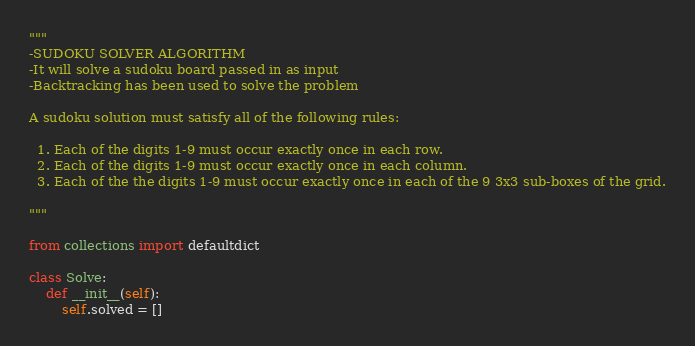Convert code to text. <code><loc_0><loc_0><loc_500><loc_500><_Python_>"""
-SUDOKU SOLVER ALGORITHM
-It will solve a sudoku board passed in as input
-Backtracking has been used to solve the problem

A sudoku solution must satisfy all of the following rules:

  1. Each of the digits 1-9 must occur exactly once in each row.
  2. Each of the digits 1-9 must occur exactly once in each column.
  3. Each of the the digits 1-9 must occur exactly once in each of the 9 3x3 sub-boxes of the grid.

"""

from collections import defaultdict

class Solve:
    def __init__(self):
        self.solved = []
</code> 